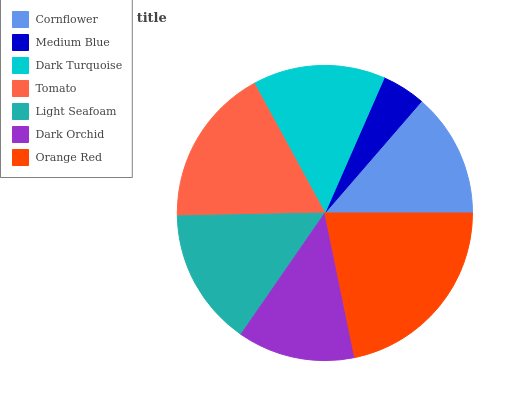Is Medium Blue the minimum?
Answer yes or no. Yes. Is Orange Red the maximum?
Answer yes or no. Yes. Is Dark Turquoise the minimum?
Answer yes or no. No. Is Dark Turquoise the maximum?
Answer yes or no. No. Is Dark Turquoise greater than Medium Blue?
Answer yes or no. Yes. Is Medium Blue less than Dark Turquoise?
Answer yes or no. Yes. Is Medium Blue greater than Dark Turquoise?
Answer yes or no. No. Is Dark Turquoise less than Medium Blue?
Answer yes or no. No. Is Dark Turquoise the high median?
Answer yes or no. Yes. Is Dark Turquoise the low median?
Answer yes or no. Yes. Is Cornflower the high median?
Answer yes or no. No. Is Tomato the low median?
Answer yes or no. No. 